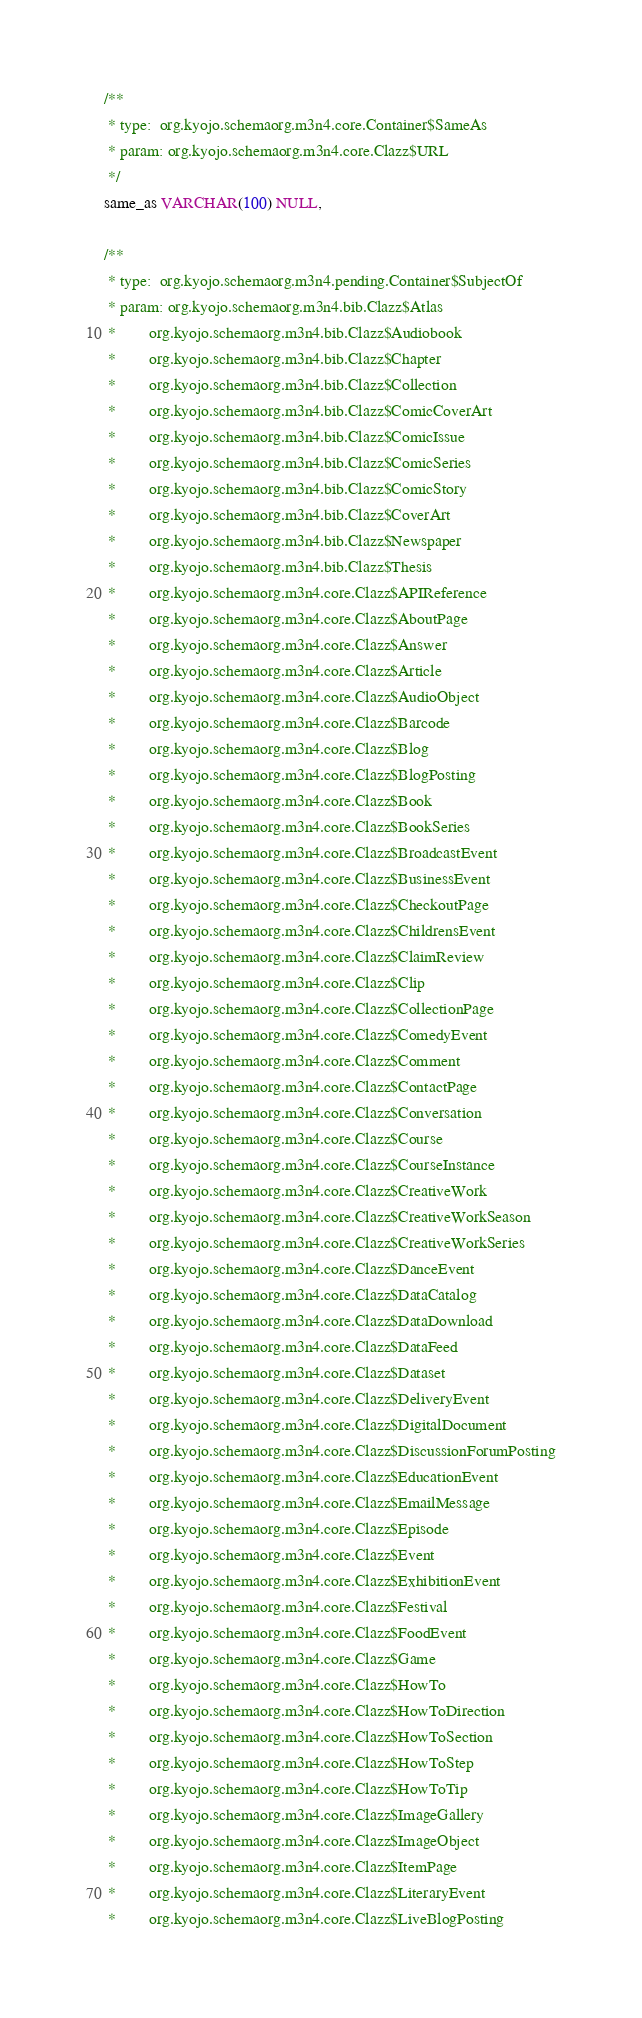<code> <loc_0><loc_0><loc_500><loc_500><_SQL_>
 /**
  * type:  org.kyojo.schemaorg.m3n4.core.Container$SameAs
  * param: org.kyojo.schemaorg.m3n4.core.Clazz$URL
  */
 same_as VARCHAR(100) NULL,

 /**
  * type:  org.kyojo.schemaorg.m3n4.pending.Container$SubjectOf
  * param: org.kyojo.schemaorg.m3n4.bib.Clazz$Atlas
  *        org.kyojo.schemaorg.m3n4.bib.Clazz$Audiobook
  *        org.kyojo.schemaorg.m3n4.bib.Clazz$Chapter
  *        org.kyojo.schemaorg.m3n4.bib.Clazz$Collection
  *        org.kyojo.schemaorg.m3n4.bib.Clazz$ComicCoverArt
  *        org.kyojo.schemaorg.m3n4.bib.Clazz$ComicIssue
  *        org.kyojo.schemaorg.m3n4.bib.Clazz$ComicSeries
  *        org.kyojo.schemaorg.m3n4.bib.Clazz$ComicStory
  *        org.kyojo.schemaorg.m3n4.bib.Clazz$CoverArt
  *        org.kyojo.schemaorg.m3n4.bib.Clazz$Newspaper
  *        org.kyojo.schemaorg.m3n4.bib.Clazz$Thesis
  *        org.kyojo.schemaorg.m3n4.core.Clazz$APIReference
  *        org.kyojo.schemaorg.m3n4.core.Clazz$AboutPage
  *        org.kyojo.schemaorg.m3n4.core.Clazz$Answer
  *        org.kyojo.schemaorg.m3n4.core.Clazz$Article
  *        org.kyojo.schemaorg.m3n4.core.Clazz$AudioObject
  *        org.kyojo.schemaorg.m3n4.core.Clazz$Barcode
  *        org.kyojo.schemaorg.m3n4.core.Clazz$Blog
  *        org.kyojo.schemaorg.m3n4.core.Clazz$BlogPosting
  *        org.kyojo.schemaorg.m3n4.core.Clazz$Book
  *        org.kyojo.schemaorg.m3n4.core.Clazz$BookSeries
  *        org.kyojo.schemaorg.m3n4.core.Clazz$BroadcastEvent
  *        org.kyojo.schemaorg.m3n4.core.Clazz$BusinessEvent
  *        org.kyojo.schemaorg.m3n4.core.Clazz$CheckoutPage
  *        org.kyojo.schemaorg.m3n4.core.Clazz$ChildrensEvent
  *        org.kyojo.schemaorg.m3n4.core.Clazz$ClaimReview
  *        org.kyojo.schemaorg.m3n4.core.Clazz$Clip
  *        org.kyojo.schemaorg.m3n4.core.Clazz$CollectionPage
  *        org.kyojo.schemaorg.m3n4.core.Clazz$ComedyEvent
  *        org.kyojo.schemaorg.m3n4.core.Clazz$Comment
  *        org.kyojo.schemaorg.m3n4.core.Clazz$ContactPage
  *        org.kyojo.schemaorg.m3n4.core.Clazz$Conversation
  *        org.kyojo.schemaorg.m3n4.core.Clazz$Course
  *        org.kyojo.schemaorg.m3n4.core.Clazz$CourseInstance
  *        org.kyojo.schemaorg.m3n4.core.Clazz$CreativeWork
  *        org.kyojo.schemaorg.m3n4.core.Clazz$CreativeWorkSeason
  *        org.kyojo.schemaorg.m3n4.core.Clazz$CreativeWorkSeries
  *        org.kyojo.schemaorg.m3n4.core.Clazz$DanceEvent
  *        org.kyojo.schemaorg.m3n4.core.Clazz$DataCatalog
  *        org.kyojo.schemaorg.m3n4.core.Clazz$DataDownload
  *        org.kyojo.schemaorg.m3n4.core.Clazz$DataFeed
  *        org.kyojo.schemaorg.m3n4.core.Clazz$Dataset
  *        org.kyojo.schemaorg.m3n4.core.Clazz$DeliveryEvent
  *        org.kyojo.schemaorg.m3n4.core.Clazz$DigitalDocument
  *        org.kyojo.schemaorg.m3n4.core.Clazz$DiscussionForumPosting
  *        org.kyojo.schemaorg.m3n4.core.Clazz$EducationEvent
  *        org.kyojo.schemaorg.m3n4.core.Clazz$EmailMessage
  *        org.kyojo.schemaorg.m3n4.core.Clazz$Episode
  *        org.kyojo.schemaorg.m3n4.core.Clazz$Event
  *        org.kyojo.schemaorg.m3n4.core.Clazz$ExhibitionEvent
  *        org.kyojo.schemaorg.m3n4.core.Clazz$Festival
  *        org.kyojo.schemaorg.m3n4.core.Clazz$FoodEvent
  *        org.kyojo.schemaorg.m3n4.core.Clazz$Game
  *        org.kyojo.schemaorg.m3n4.core.Clazz$HowTo
  *        org.kyojo.schemaorg.m3n4.core.Clazz$HowToDirection
  *        org.kyojo.schemaorg.m3n4.core.Clazz$HowToSection
  *        org.kyojo.schemaorg.m3n4.core.Clazz$HowToStep
  *        org.kyojo.schemaorg.m3n4.core.Clazz$HowToTip
  *        org.kyojo.schemaorg.m3n4.core.Clazz$ImageGallery
  *        org.kyojo.schemaorg.m3n4.core.Clazz$ImageObject
  *        org.kyojo.schemaorg.m3n4.core.Clazz$ItemPage
  *        org.kyojo.schemaorg.m3n4.core.Clazz$LiteraryEvent
  *        org.kyojo.schemaorg.m3n4.core.Clazz$LiveBlogPosting</code> 